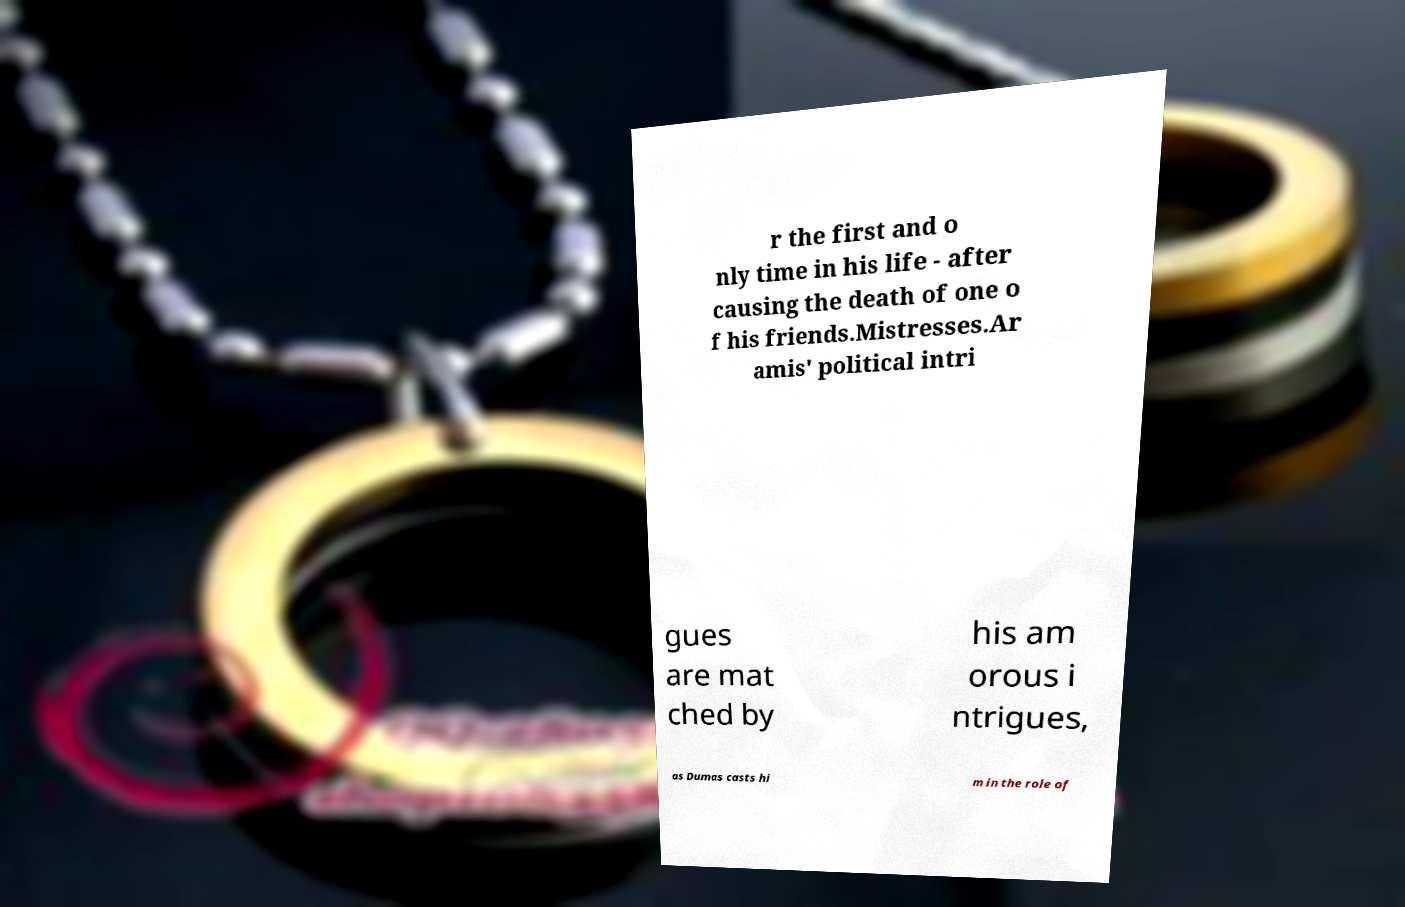Could you assist in decoding the text presented in this image and type it out clearly? r the first and o nly time in his life - after causing the death of one o f his friends.Mistresses.Ar amis' political intri gues are mat ched by his am orous i ntrigues, as Dumas casts hi m in the role of 